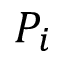Convert formula to latex. <formula><loc_0><loc_0><loc_500><loc_500>P _ { i }</formula> 